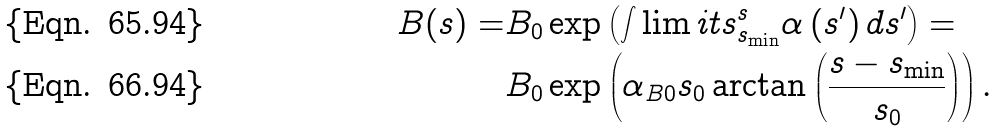<formula> <loc_0><loc_0><loc_500><loc_500>B ( s ) = & B _ { 0 } \exp \left ( \int \lim i t s _ { s _ { \min } } ^ { s } \alpha \left ( s ^ { \prime } \right ) d s ^ { \prime } \right ) = \\ & B _ { 0 } \exp \left ( \alpha _ { B 0 } s _ { 0 } \arctan \left ( \frac { s - s _ { \min } } { s _ { 0 } } \right ) \right ) .</formula> 